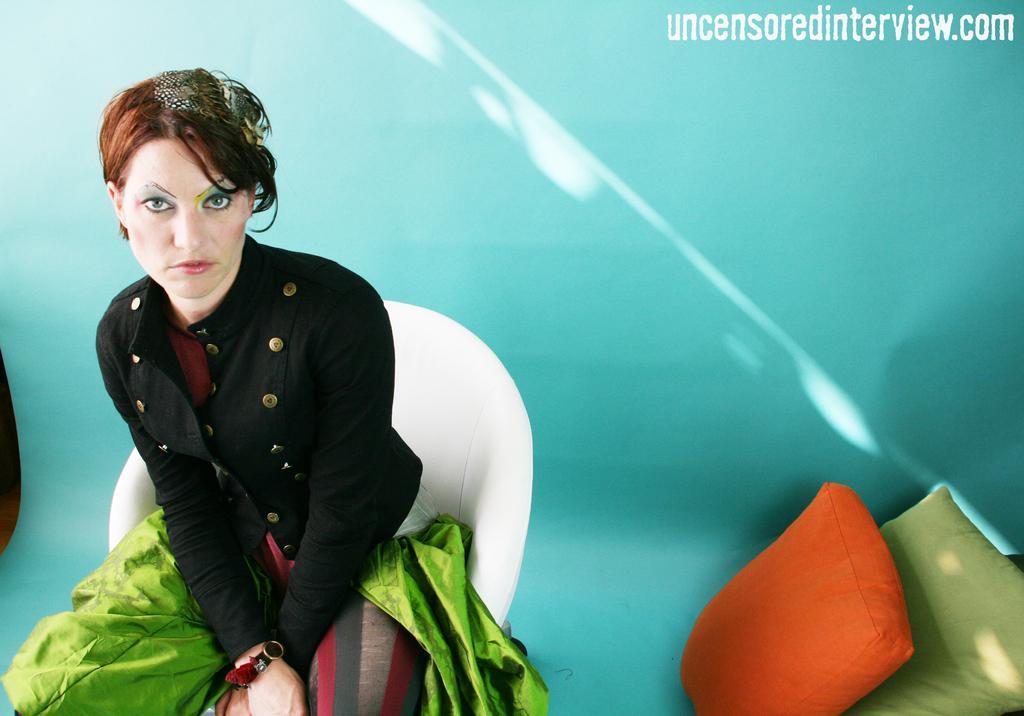Please provide a concise description of this image. In this picture I can observe a woman sitting in the white color chair. She is wearing black and green color dress. On the right side I can observe an orange and green color pillows. In the background there is a blue color wall. On the top right side I can observe some text in this picture. 